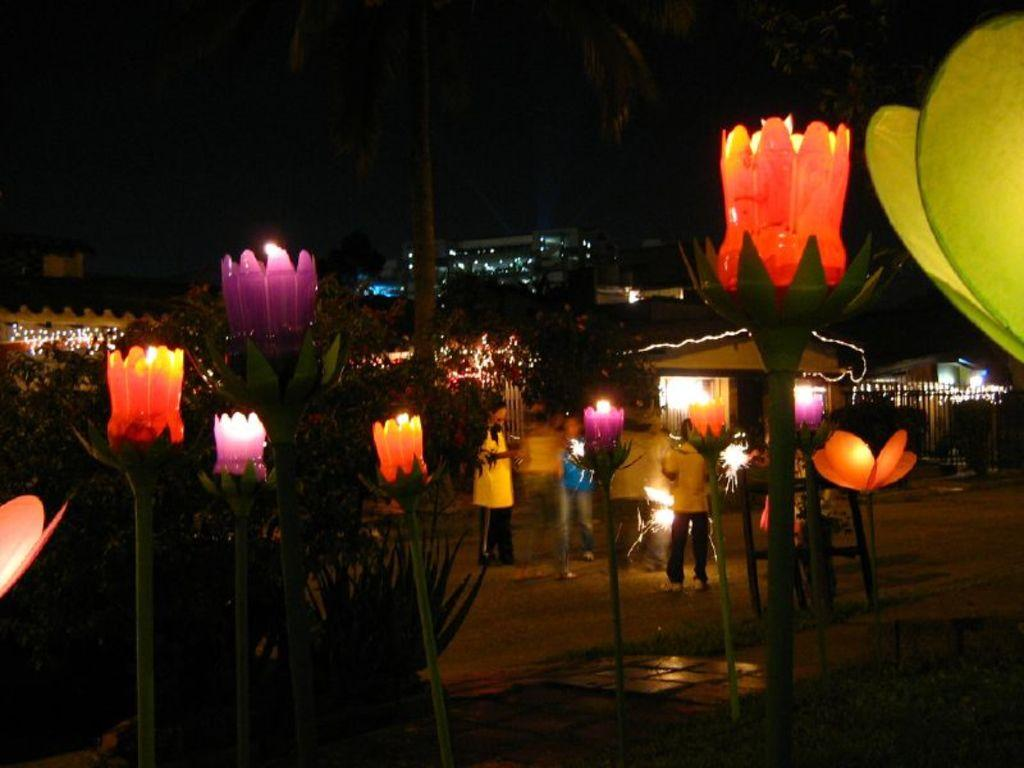What are the people in the image doing? The people in the image are standing on the ground. What can be seen in the background of the image? There is a house, buildings, and trees in the background of the image. What objects are visible in the front of the image? Candles are visible in the front of the image. What type of minister is depicted in the image? There is no minister present in the image. What facial expression do the people in the image have? The provided facts do not mention the facial expressions of the people in the image. 